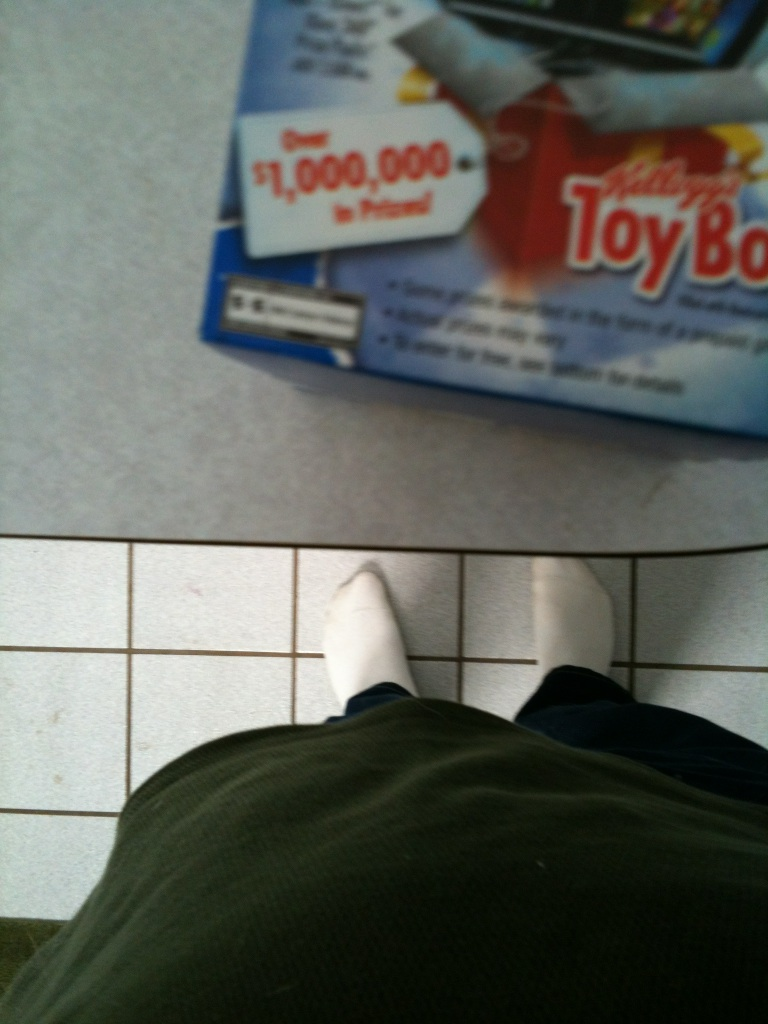What is the significance of the number '1,000,000' shown on the box? The number '1,000,000' likely indicates a promotional event or contest associated with the product, offering a reward or prize to participants. How can participants join this contest? Participants might need to purchase the product and follow specific contest rules stated on the package or refer to the company’s promotional website for more details. 